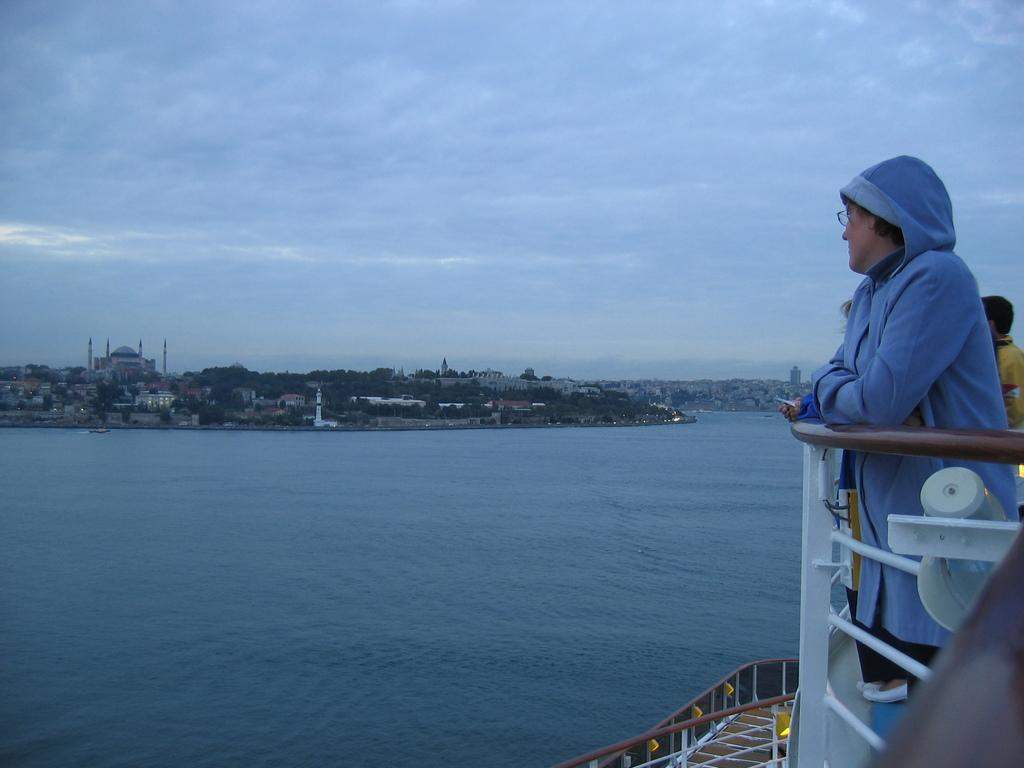How many people can be seen in the image? There are people in the image, but the exact number is not specified. What type of surface is visible beneath the people? There is ground visible in the image. What type of structures are present in the image? Metallic poles, buildings, and a fort are present in the image. What natural elements can be seen in the image? Trees and water are visible in the image. What part of the natural environment is visible in the image? The sky is visible in the image, with clouds visible as well. What type of toothbrush is being used by the people in the image? There is no toothbrush present in the image. What dish are the people in the image cooking? There is no cooking activity depicted in the image. 